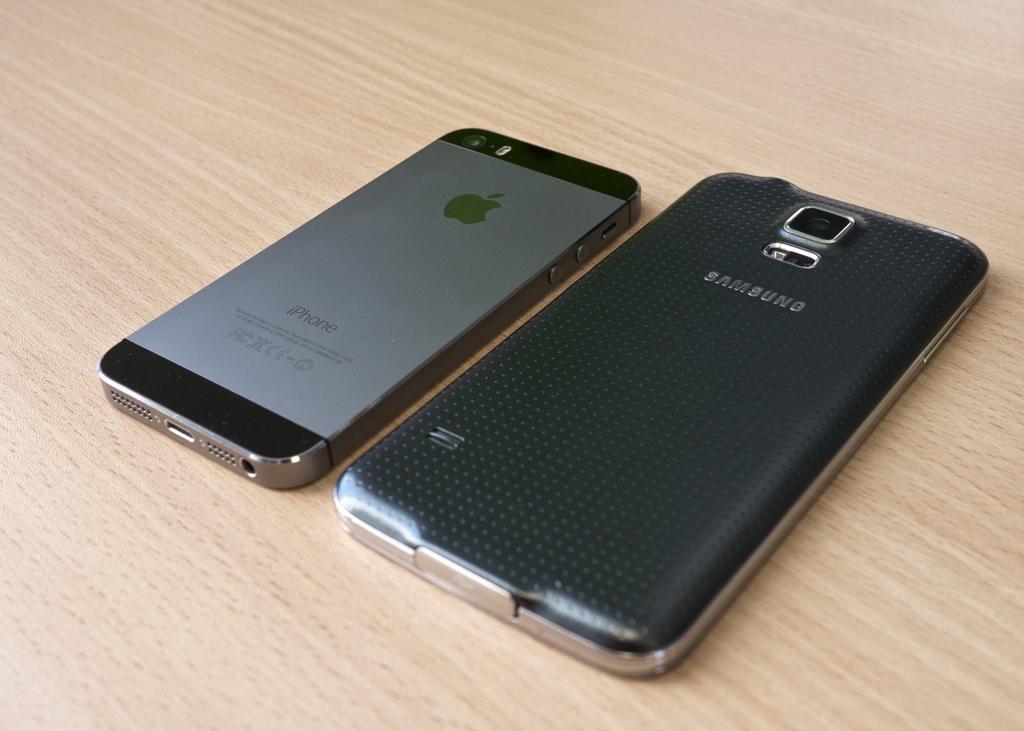Describe this image in one or two sentences. In this picture I can see the iPhone and Samsung mobile phone which is kept on the table. 